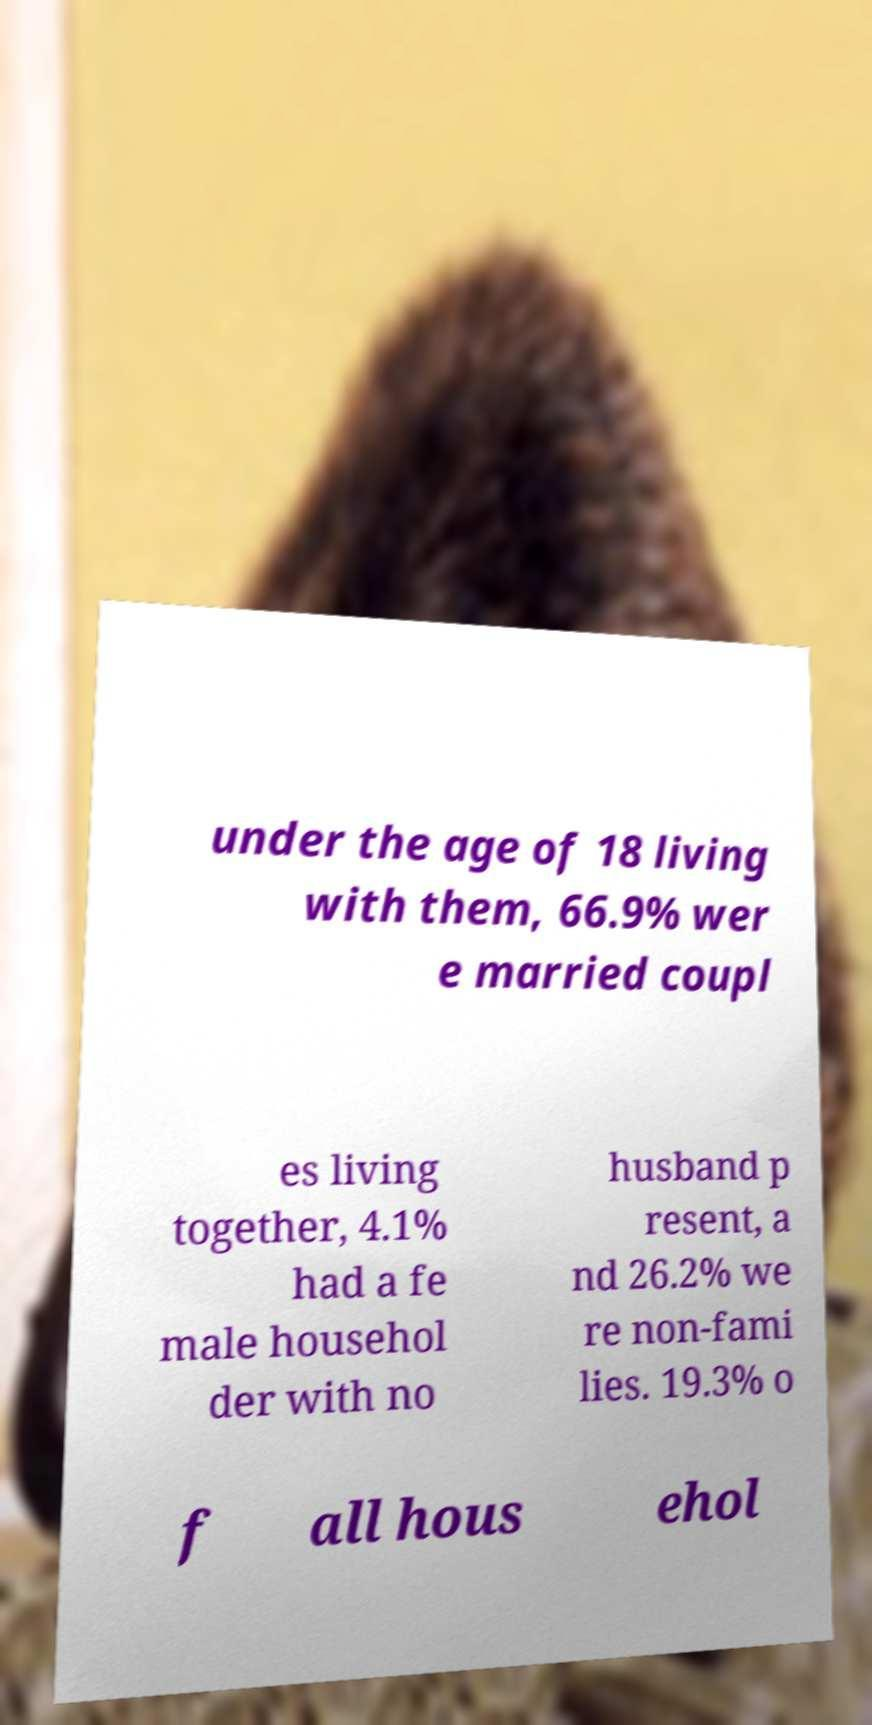Could you assist in decoding the text presented in this image and type it out clearly? under the age of 18 living with them, 66.9% wer e married coupl es living together, 4.1% had a fe male househol der with no husband p resent, a nd 26.2% we re non-fami lies. 19.3% o f all hous ehol 